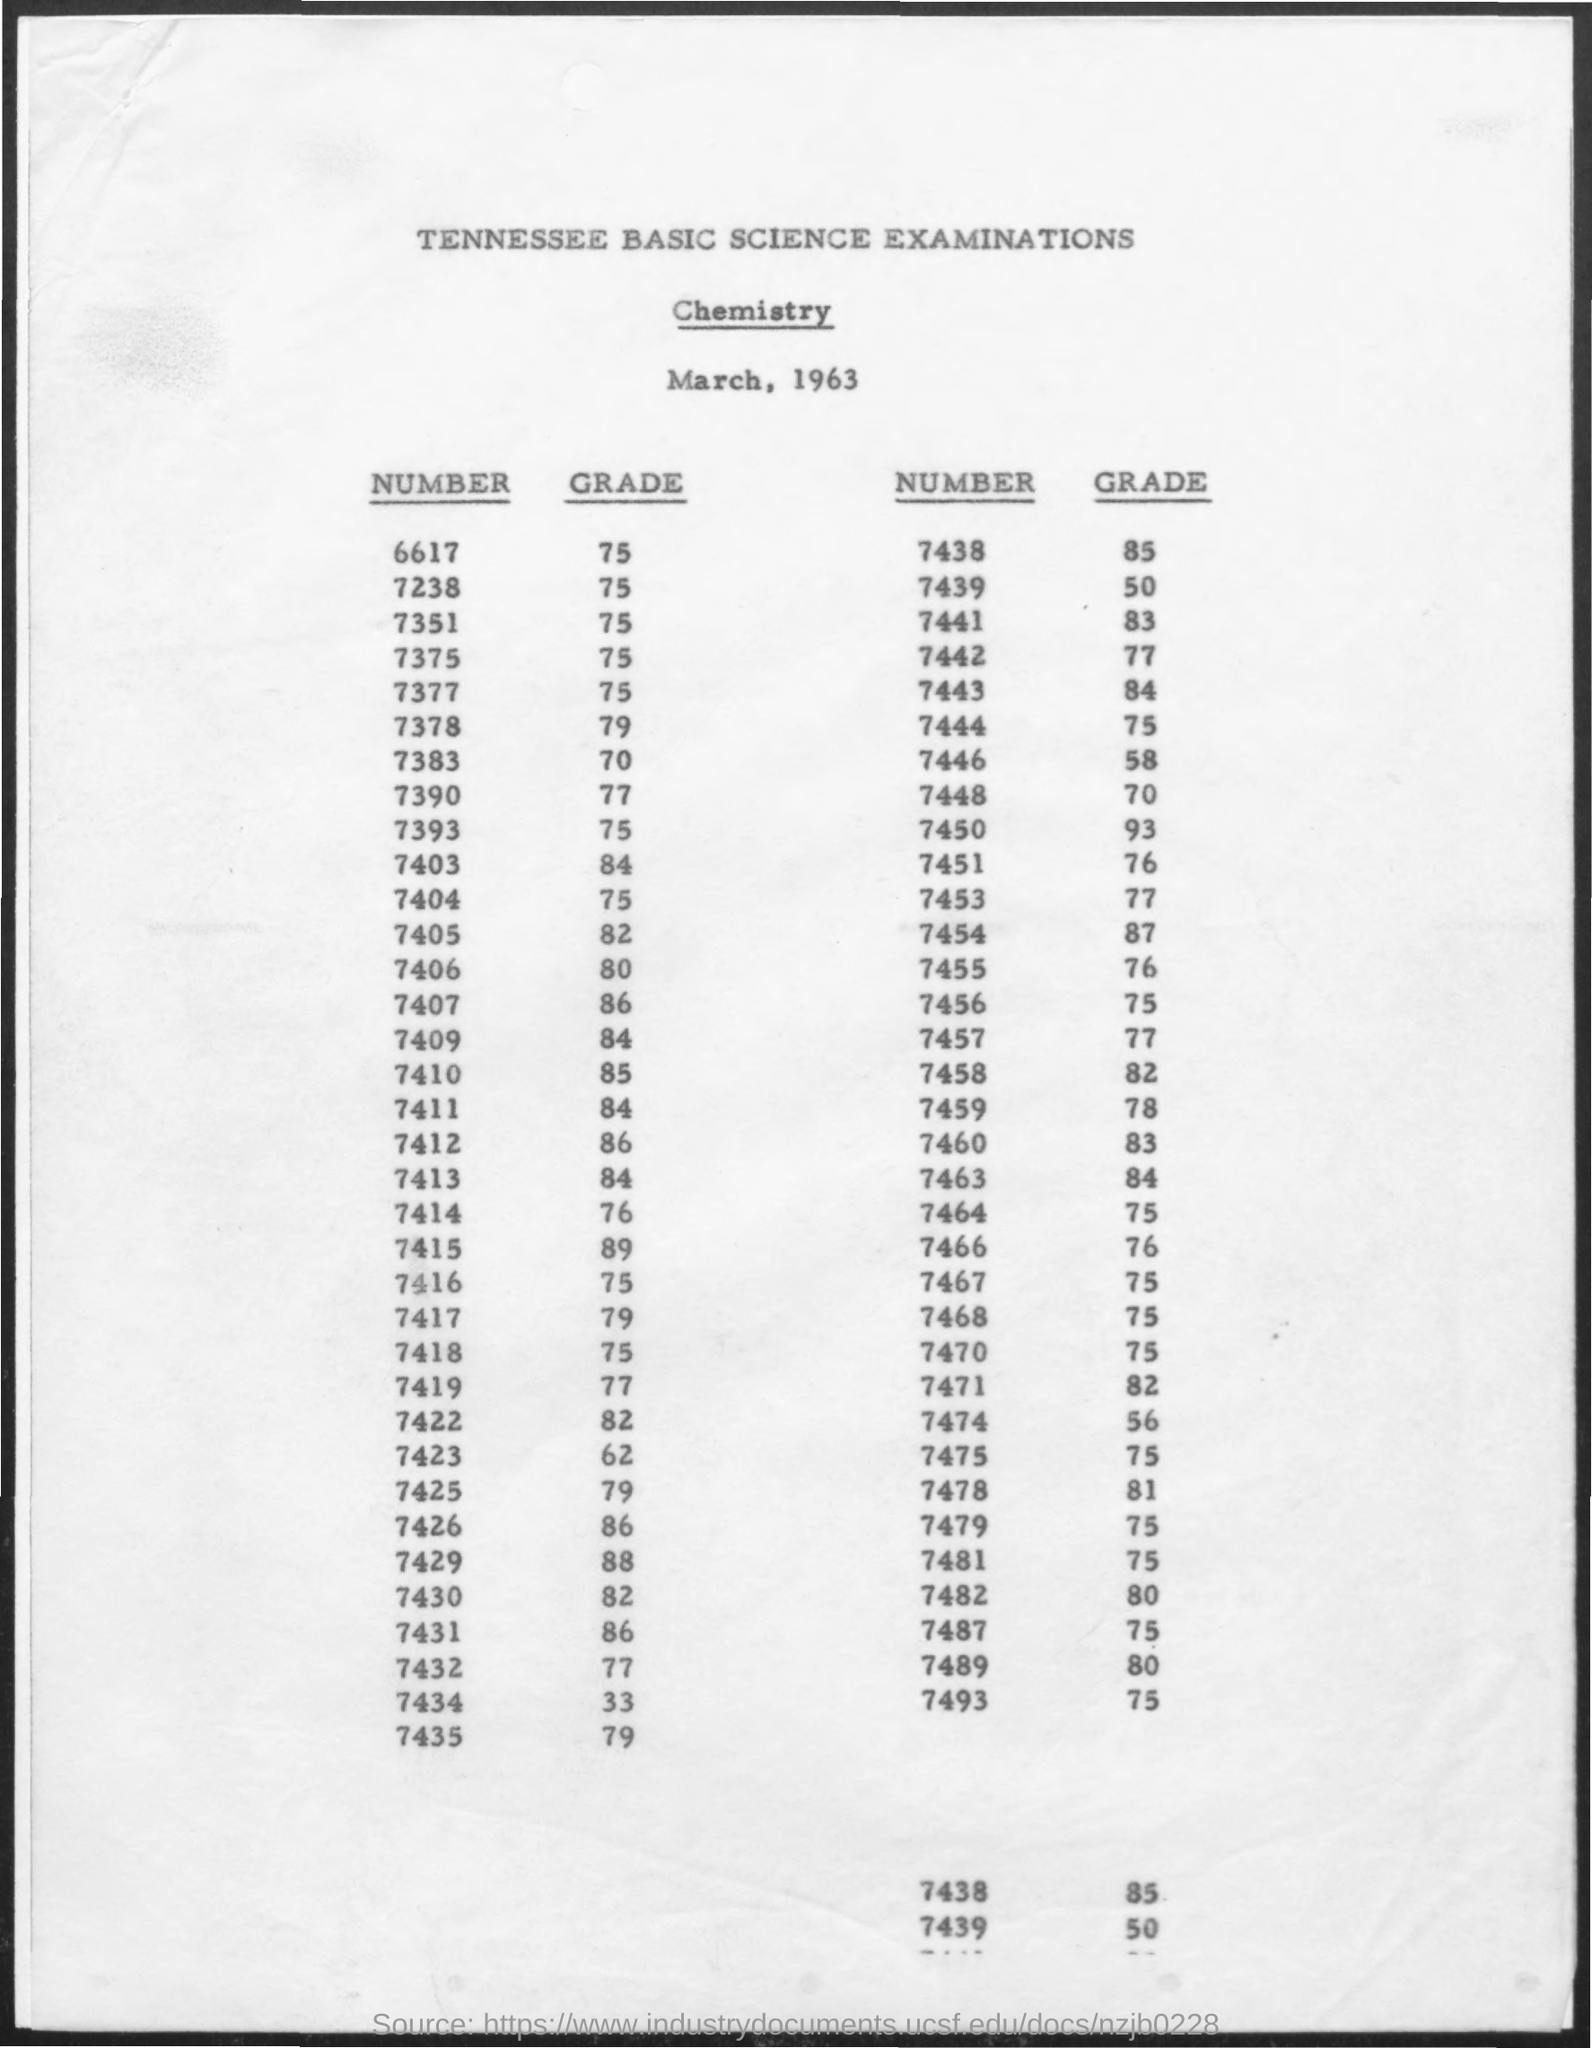What is the date mentioned ?
Your response must be concise. March, 1963. What is the grade for the number 6617 ?
Provide a short and direct response. 75. What is the grade for the number 7438 ?
Offer a very short reply. 85. What is the grade for the number  7441 ?
Your answer should be very brief. 83. What is the grade for the number 7390 ?
Provide a short and direct response. 77. What is the grade for the number 7377 ?
Ensure brevity in your answer.  75. What is the grade for the number 7463 ?
Offer a very short reply. 84. What is the grade for the number 7393 ?
Keep it short and to the point. 75. What is the grade for the number 7435 ?
Keep it short and to the point. 79. What is the grade for the number 7481 ?
Your answer should be very brief. 75. 